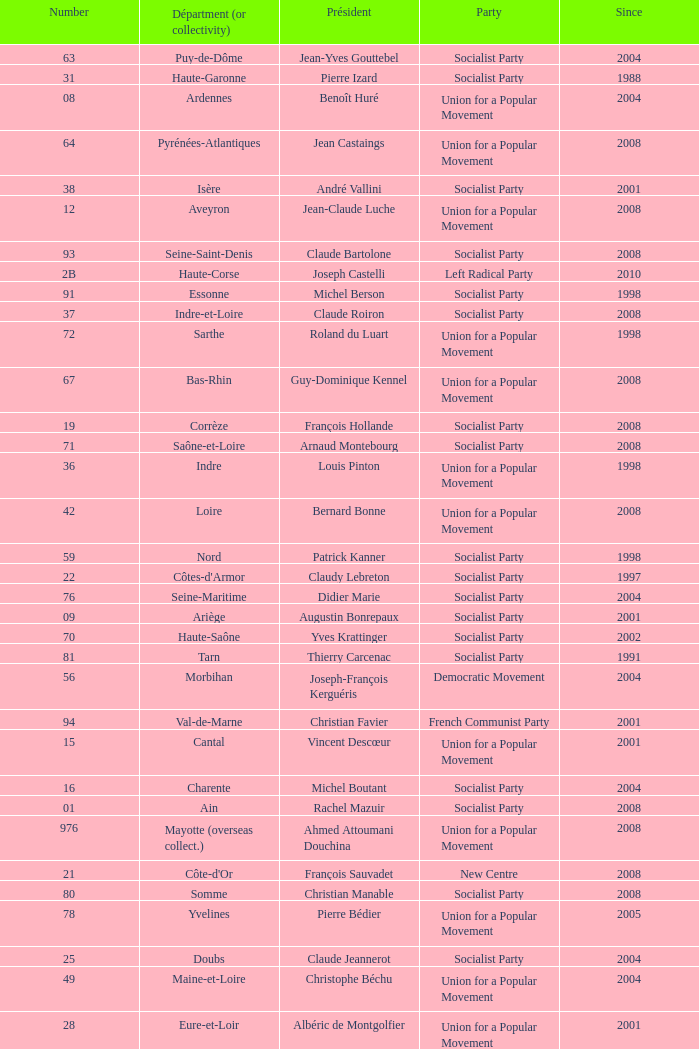Who is the president from the Union for a Popular Movement party that represents the Hautes-Alpes department? Jean-Yves Dusserre. 